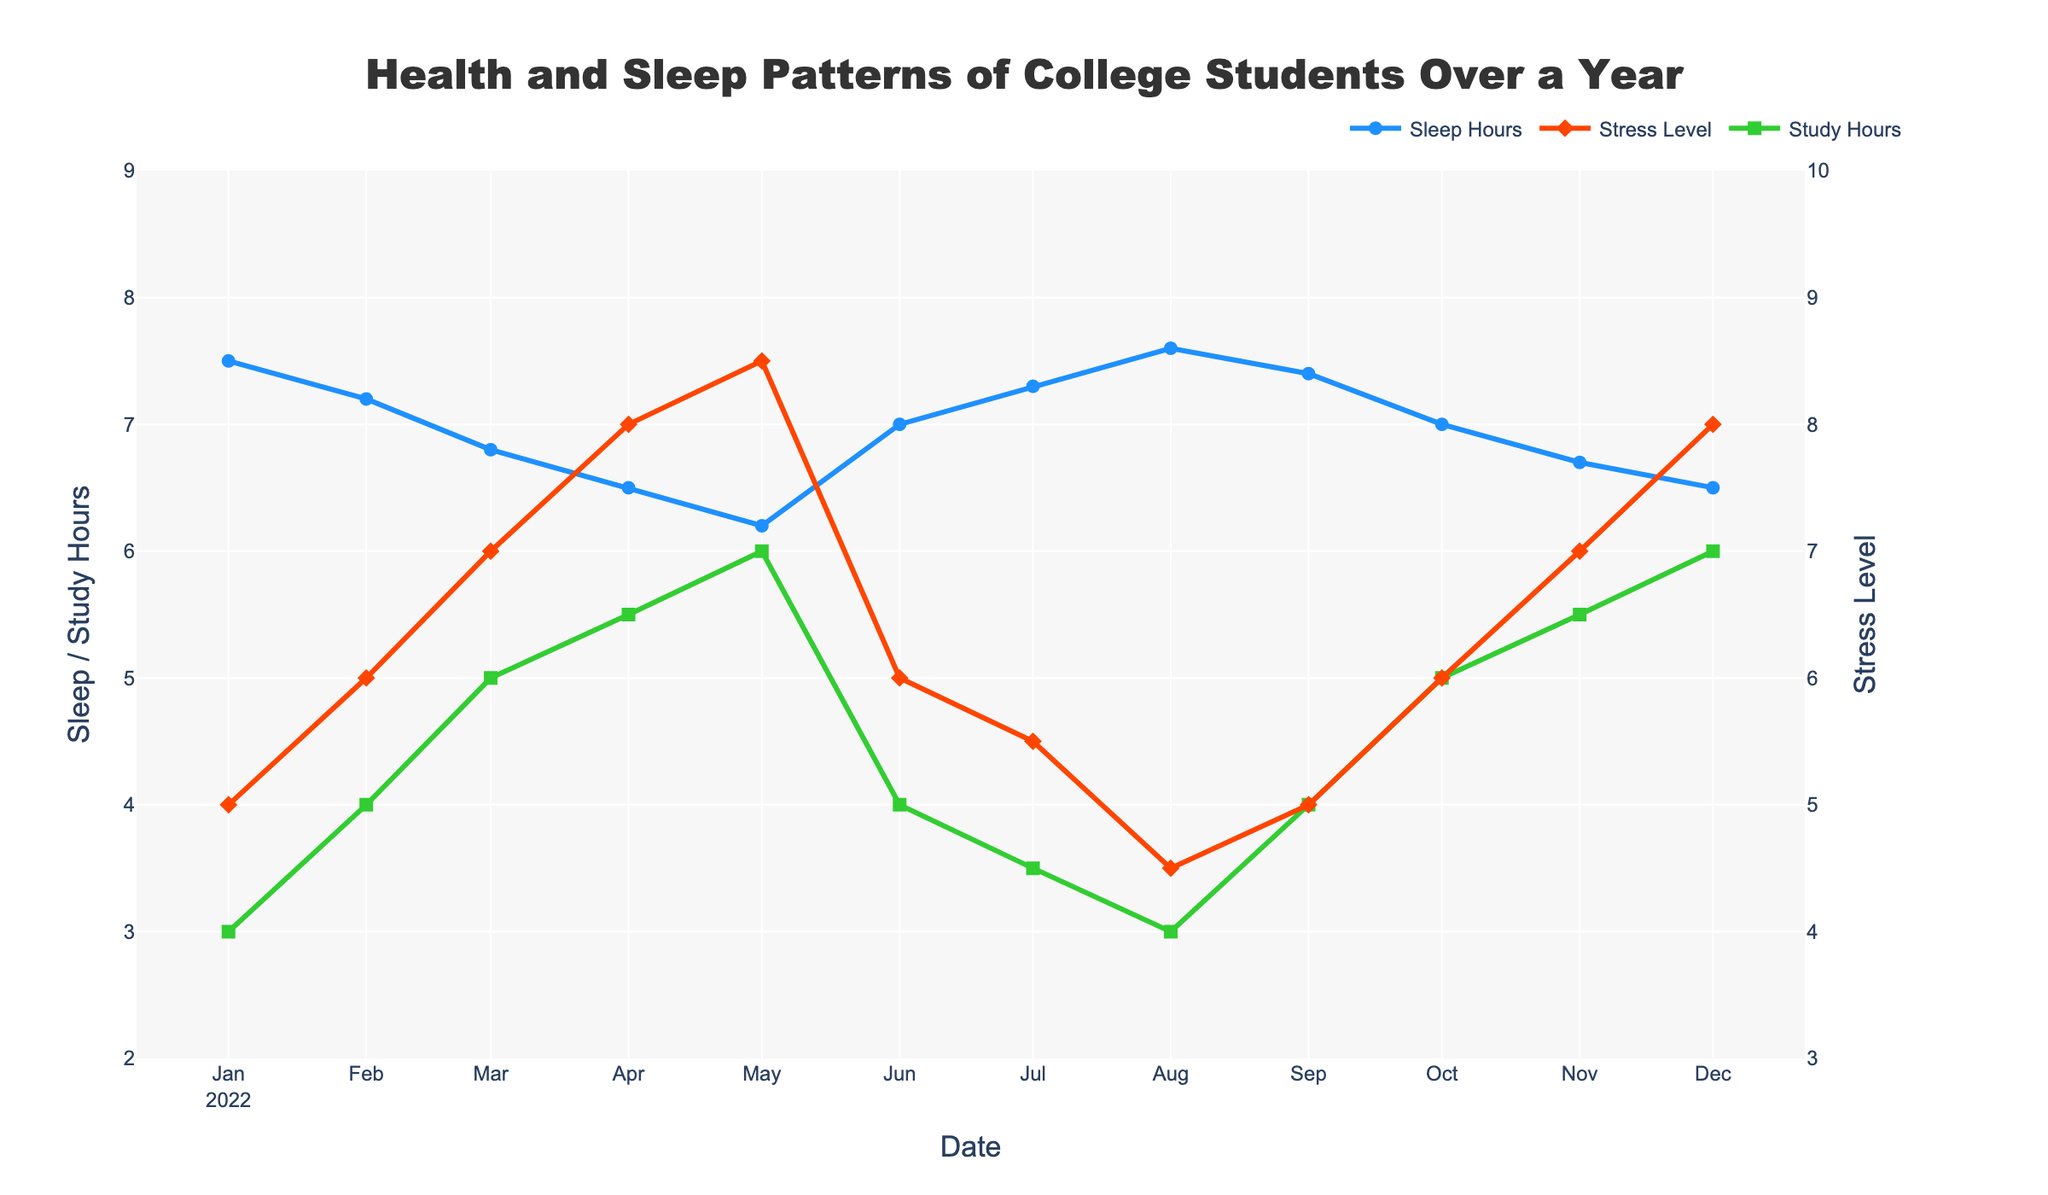How many different data points are plotted in the figure? The figure contains three different lines: Sleep Hours, Stress Level, and Study Hours, each spanning 12 months. So, there are 3 lines x 12 months = 36 data points.
Answer: 36 What trend do you see in average sleep hours over the year? The average sleep hours generally decrease from January to May, reaching a low point in May and then increase again towards August, with slight fluctuations until December.
Answer: Decrease, then increase What month has the highest average stress level? By looking at the highest points on the Stress Level line plotted in red, we find that both April and May have the highest stress levels, both at 8.5.
Answer: April and May In which month do the average study hours peak? By observing the green Study Hours line, the peak occurs in December, where the value reaches the highest point of 6 hours.
Answer: December What is the relationship between stress level and sleep hours in November? In November, the stress level is at 7 and the sleep hours are at 6.7. It shows that higher stress levels correspond to lower sleep hours compared to other months.
Answer: Higher stress, lower sleep How does the average sleep hours in January compare to that in October? January has an average sleep of 7.5 hours and October has 7.0 hours. Thus, January has higher average sleep hours than October.
Answer: Higher in January What is the difference in average study hours between March and August? In March, the average study hours are 5, and in August, it is 3. The difference is 5 - 3 = 2 hours.
Answer: 2 hours Is there any month where all three variables (Sleep Hours, Stress Level, Study Hours) have their lowest or highest values? By examining the plot, no single month has all three variables peaking or hitting lows together. The variables exhibit different peak and low months.
Answer: No What happens to stress levels during the summer months (June, July, August)? Stress levels decrease from 6 in June to 4.5 in August, showing a downward trend during the summer.
Answer: Decrease Which variable has the most consistent pattern over the year? The green Study Hours line appears relatively consistent with smaller fluctuations compared to Sleep Hours and Stress Level lines, which show more significant variations.
Answer: Study Hours 